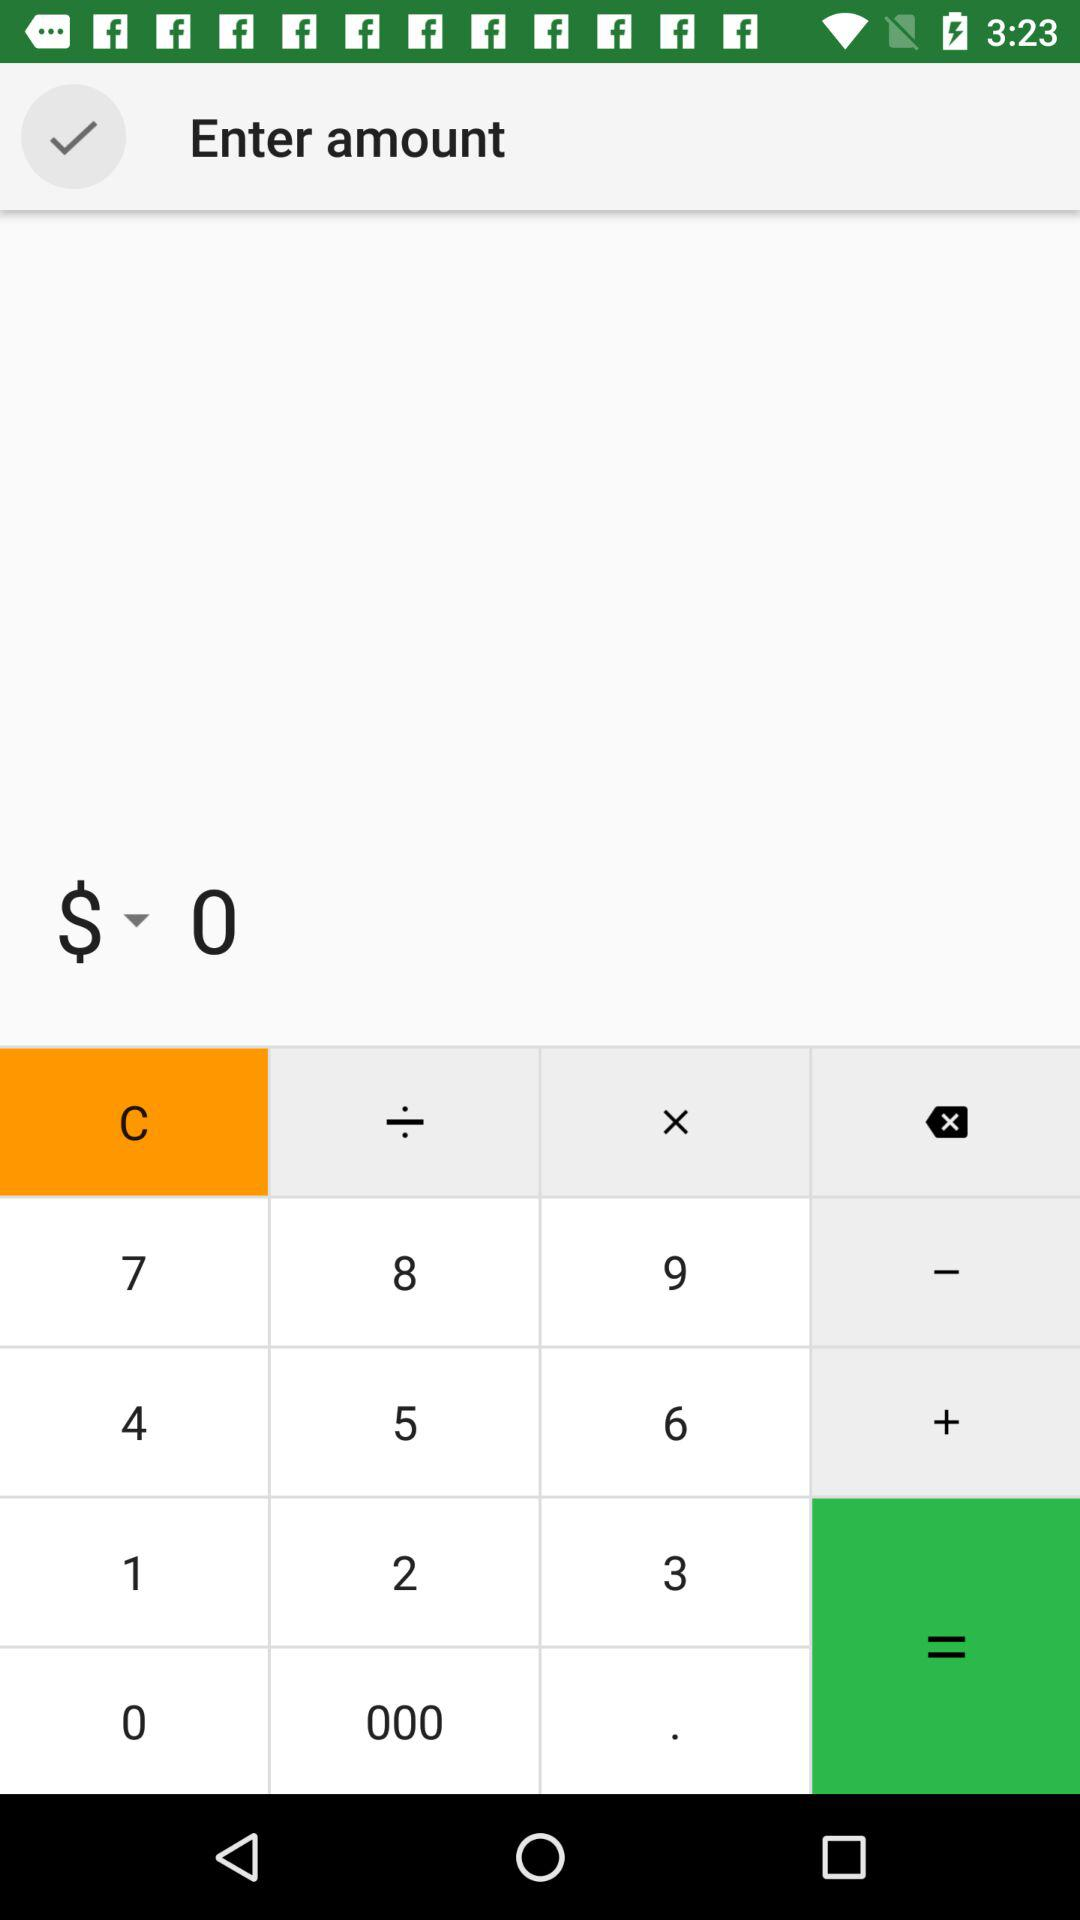What is the entered amount? The entered amount is $0. 